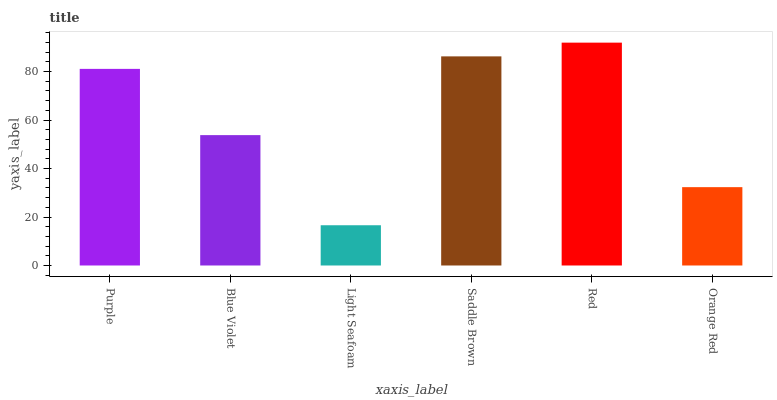Is Light Seafoam the minimum?
Answer yes or no. Yes. Is Red the maximum?
Answer yes or no. Yes. Is Blue Violet the minimum?
Answer yes or no. No. Is Blue Violet the maximum?
Answer yes or no. No. Is Purple greater than Blue Violet?
Answer yes or no. Yes. Is Blue Violet less than Purple?
Answer yes or no. Yes. Is Blue Violet greater than Purple?
Answer yes or no. No. Is Purple less than Blue Violet?
Answer yes or no. No. Is Purple the high median?
Answer yes or no. Yes. Is Blue Violet the low median?
Answer yes or no. Yes. Is Blue Violet the high median?
Answer yes or no. No. Is Red the low median?
Answer yes or no. No. 